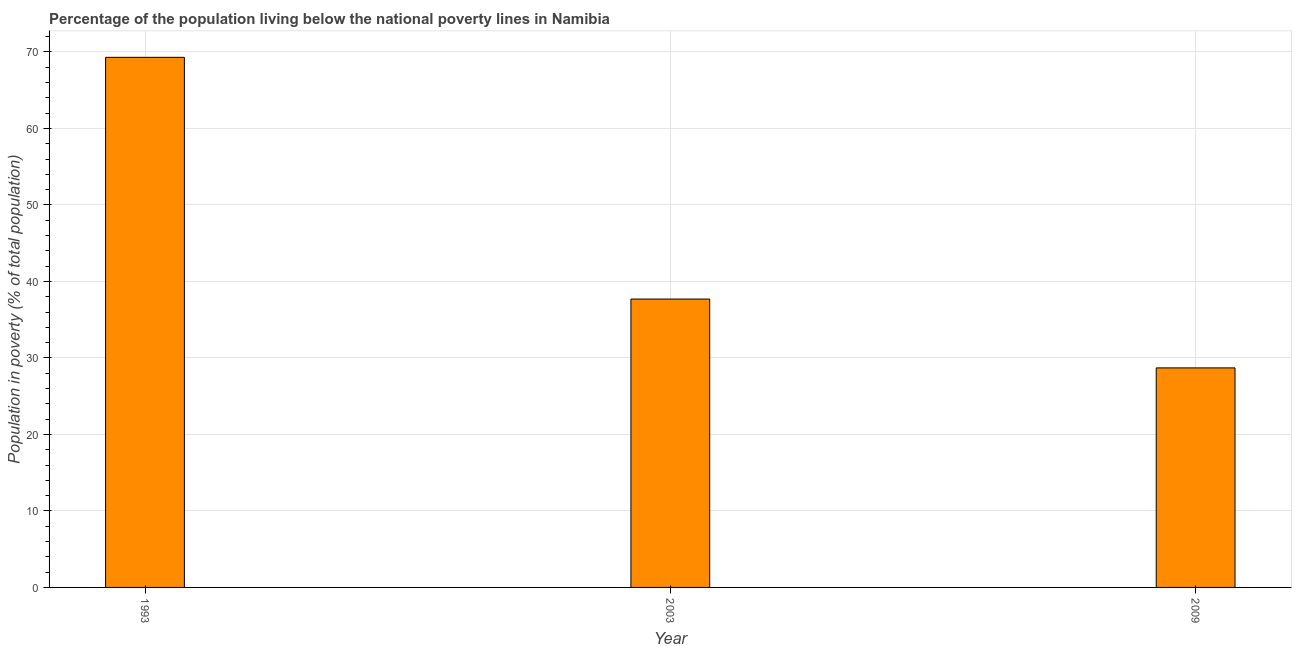What is the title of the graph?
Your answer should be compact. Percentage of the population living below the national poverty lines in Namibia. What is the label or title of the Y-axis?
Make the answer very short. Population in poverty (% of total population). What is the percentage of population living below poverty line in 2009?
Offer a very short reply. 28.7. Across all years, what is the maximum percentage of population living below poverty line?
Your answer should be compact. 69.3. Across all years, what is the minimum percentage of population living below poverty line?
Your answer should be compact. 28.7. In which year was the percentage of population living below poverty line maximum?
Offer a terse response. 1993. What is the sum of the percentage of population living below poverty line?
Make the answer very short. 135.7. What is the difference between the percentage of population living below poverty line in 1993 and 2009?
Your answer should be compact. 40.6. What is the average percentage of population living below poverty line per year?
Give a very brief answer. 45.23. What is the median percentage of population living below poverty line?
Provide a succinct answer. 37.7. In how many years, is the percentage of population living below poverty line greater than 10 %?
Offer a terse response. 3. What is the ratio of the percentage of population living below poverty line in 2003 to that in 2009?
Offer a very short reply. 1.31. Is the difference between the percentage of population living below poverty line in 2003 and 2009 greater than the difference between any two years?
Offer a terse response. No. What is the difference between the highest and the second highest percentage of population living below poverty line?
Your response must be concise. 31.6. What is the difference between the highest and the lowest percentage of population living below poverty line?
Your answer should be compact. 40.6. In how many years, is the percentage of population living below poverty line greater than the average percentage of population living below poverty line taken over all years?
Your response must be concise. 1. How many bars are there?
Make the answer very short. 3. What is the difference between two consecutive major ticks on the Y-axis?
Ensure brevity in your answer.  10. What is the Population in poverty (% of total population) of 1993?
Ensure brevity in your answer.  69.3. What is the Population in poverty (% of total population) of 2003?
Provide a short and direct response. 37.7. What is the Population in poverty (% of total population) in 2009?
Offer a very short reply. 28.7. What is the difference between the Population in poverty (% of total population) in 1993 and 2003?
Your response must be concise. 31.6. What is the difference between the Population in poverty (% of total population) in 1993 and 2009?
Keep it short and to the point. 40.6. What is the ratio of the Population in poverty (% of total population) in 1993 to that in 2003?
Ensure brevity in your answer.  1.84. What is the ratio of the Population in poverty (% of total population) in 1993 to that in 2009?
Offer a terse response. 2.42. What is the ratio of the Population in poverty (% of total population) in 2003 to that in 2009?
Keep it short and to the point. 1.31. 